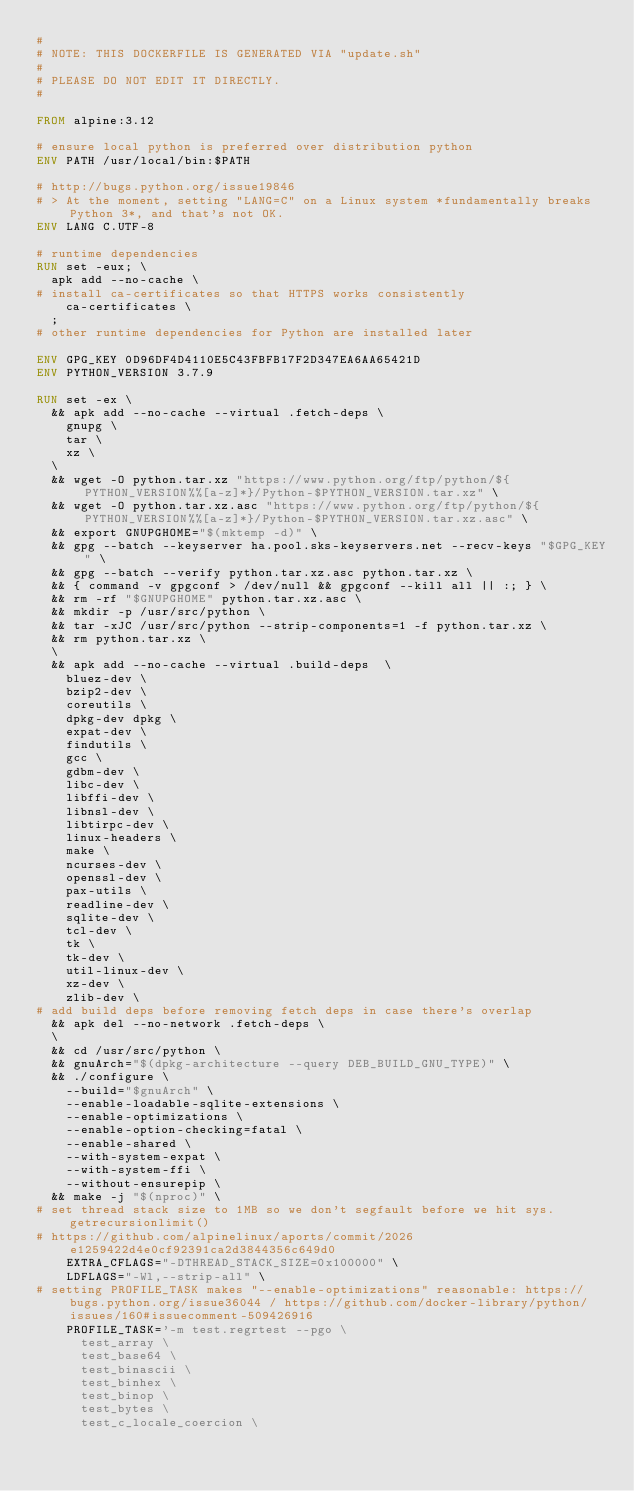<code> <loc_0><loc_0><loc_500><loc_500><_Dockerfile_>#
# NOTE: THIS DOCKERFILE IS GENERATED VIA "update.sh"
#
# PLEASE DO NOT EDIT IT DIRECTLY.
#

FROM alpine:3.12

# ensure local python is preferred over distribution python
ENV PATH /usr/local/bin:$PATH

# http://bugs.python.org/issue19846
# > At the moment, setting "LANG=C" on a Linux system *fundamentally breaks Python 3*, and that's not OK.
ENV LANG C.UTF-8

# runtime dependencies
RUN set -eux; \
	apk add --no-cache \
# install ca-certificates so that HTTPS works consistently
		ca-certificates \
	;
# other runtime dependencies for Python are installed later

ENV GPG_KEY 0D96DF4D4110E5C43FBFB17F2D347EA6AA65421D
ENV PYTHON_VERSION 3.7.9

RUN set -ex \
	&& apk add --no-cache --virtual .fetch-deps \
		gnupg \
		tar \
		xz \
	\
	&& wget -O python.tar.xz "https://www.python.org/ftp/python/${PYTHON_VERSION%%[a-z]*}/Python-$PYTHON_VERSION.tar.xz" \
	&& wget -O python.tar.xz.asc "https://www.python.org/ftp/python/${PYTHON_VERSION%%[a-z]*}/Python-$PYTHON_VERSION.tar.xz.asc" \
	&& export GNUPGHOME="$(mktemp -d)" \
	&& gpg --batch --keyserver ha.pool.sks-keyservers.net --recv-keys "$GPG_KEY" \
	&& gpg --batch --verify python.tar.xz.asc python.tar.xz \
	&& { command -v gpgconf > /dev/null && gpgconf --kill all || :; } \
	&& rm -rf "$GNUPGHOME" python.tar.xz.asc \
	&& mkdir -p /usr/src/python \
	&& tar -xJC /usr/src/python --strip-components=1 -f python.tar.xz \
	&& rm python.tar.xz \
	\
	&& apk add --no-cache --virtual .build-deps  \
		bluez-dev \
		bzip2-dev \
		coreutils \
		dpkg-dev dpkg \
		expat-dev \
		findutils \
		gcc \
		gdbm-dev \
		libc-dev \
		libffi-dev \
		libnsl-dev \
		libtirpc-dev \
		linux-headers \
		make \
		ncurses-dev \
		openssl-dev \
		pax-utils \
		readline-dev \
		sqlite-dev \
		tcl-dev \
		tk \
		tk-dev \
		util-linux-dev \
		xz-dev \
		zlib-dev \
# add build deps before removing fetch deps in case there's overlap
	&& apk del --no-network .fetch-deps \
	\
	&& cd /usr/src/python \
	&& gnuArch="$(dpkg-architecture --query DEB_BUILD_GNU_TYPE)" \
	&& ./configure \
		--build="$gnuArch" \
		--enable-loadable-sqlite-extensions \
		--enable-optimizations \
		--enable-option-checking=fatal \
		--enable-shared \
		--with-system-expat \
		--with-system-ffi \
		--without-ensurepip \
	&& make -j "$(nproc)" \
# set thread stack size to 1MB so we don't segfault before we hit sys.getrecursionlimit()
# https://github.com/alpinelinux/aports/commit/2026e1259422d4e0cf92391ca2d3844356c649d0
		EXTRA_CFLAGS="-DTHREAD_STACK_SIZE=0x100000" \
		LDFLAGS="-Wl,--strip-all" \
# setting PROFILE_TASK makes "--enable-optimizations" reasonable: https://bugs.python.org/issue36044 / https://github.com/docker-library/python/issues/160#issuecomment-509426916
		PROFILE_TASK='-m test.regrtest --pgo \
			test_array \
			test_base64 \
			test_binascii \
			test_binhex \
			test_binop \
			test_bytes \
			test_c_locale_coercion \</code> 